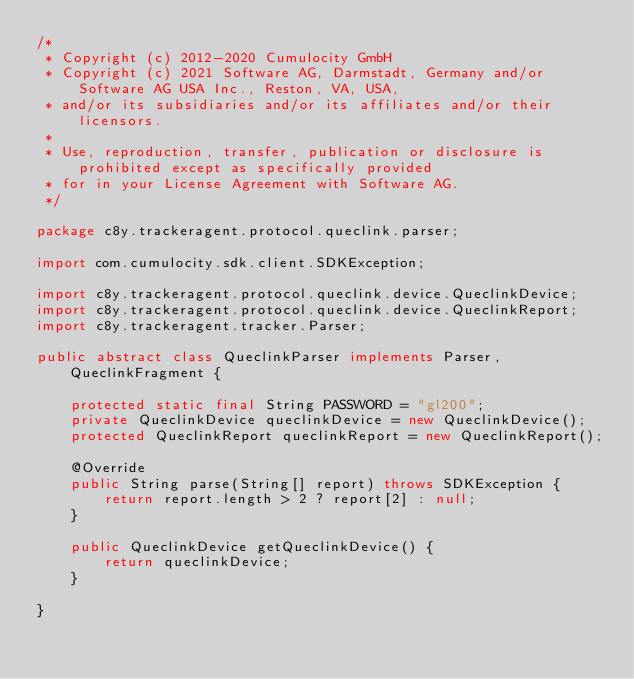Convert code to text. <code><loc_0><loc_0><loc_500><loc_500><_Java_>/*
 * Copyright (c) 2012-2020 Cumulocity GmbH
 * Copyright (c) 2021 Software AG, Darmstadt, Germany and/or Software AG USA Inc., Reston, VA, USA,
 * and/or its subsidiaries and/or its affiliates and/or their licensors.
 *
 * Use, reproduction, transfer, publication or disclosure is prohibited except as specifically provided
 * for in your License Agreement with Software AG.
 */

package c8y.trackeragent.protocol.queclink.parser;

import com.cumulocity.sdk.client.SDKException;

import c8y.trackeragent.protocol.queclink.device.QueclinkDevice;
import c8y.trackeragent.protocol.queclink.device.QueclinkReport;
import c8y.trackeragent.tracker.Parser;

public abstract class QueclinkParser implements Parser, QueclinkFragment {
    
    protected static final String PASSWORD = "gl200";
    private QueclinkDevice queclinkDevice = new QueclinkDevice();
    protected QueclinkReport queclinkReport = new QueclinkReport();
    
    @Override
    public String parse(String[] report) throws SDKException {
        return report.length > 2 ? report[2] : null;
    }
    
    public QueclinkDevice getQueclinkDevice() {
        return queclinkDevice;
    }

}
</code> 